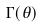<formula> <loc_0><loc_0><loc_500><loc_500>\Gamma ( \theta )</formula> 